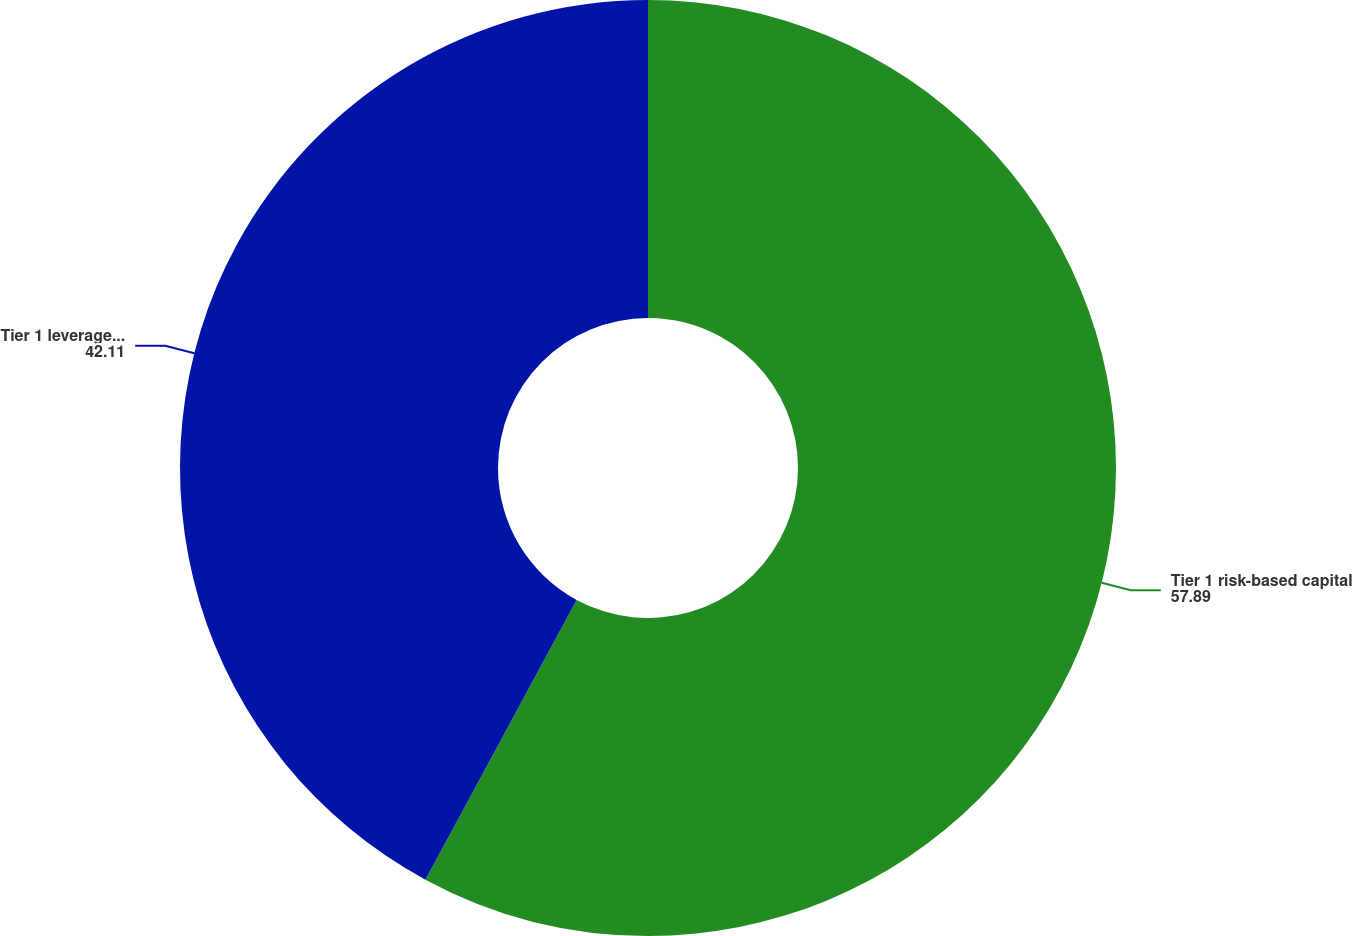Convert chart. <chart><loc_0><loc_0><loc_500><loc_500><pie_chart><fcel>Tier 1 risk-based capital<fcel>Tier 1 leverage ratio<nl><fcel>57.89%<fcel>42.11%<nl></chart> 